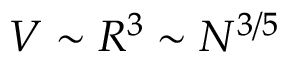Convert formula to latex. <formula><loc_0><loc_0><loc_500><loc_500>V \sim R ^ { 3 } \sim N ^ { 3 / 5 }</formula> 